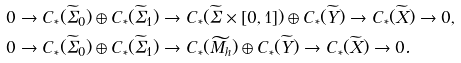<formula> <loc_0><loc_0><loc_500><loc_500>& 0 \to C _ { * } ( \widetilde { \Sigma } _ { 0 } ) \oplus C _ { * } ( \widetilde { \Sigma } _ { 1 } ) \to C _ { * } ( \widetilde { \Sigma } \times [ 0 , 1 ] ) \oplus C _ { * } ( \widetilde { Y } ) \to C _ { * } ( \widetilde { X } ) \to 0 , \\ & 0 \to C _ { * } ( \widetilde { \Sigma } _ { 0 } ) \oplus C _ { * } ( \widetilde { \Sigma } _ { 1 } ) \to C _ { * } ( \widetilde { M _ { h } } ) \oplus C _ { * } ( \widetilde { Y } ) \to C _ { * } ( \widetilde { X } ) \to 0 .</formula> 